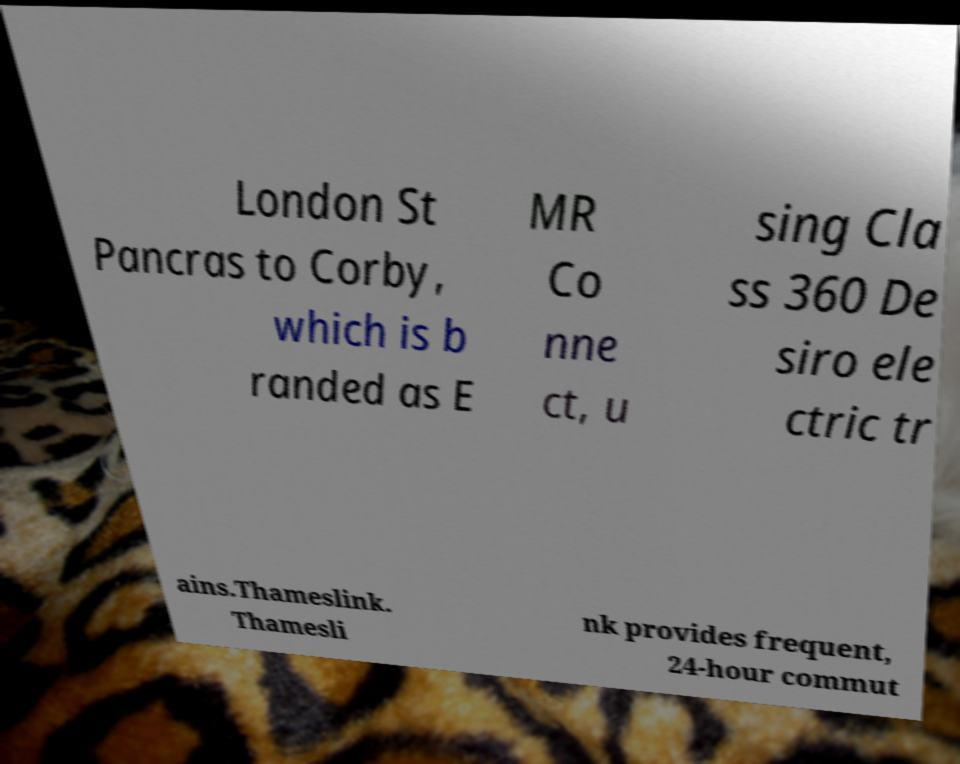Can you accurately transcribe the text from the provided image for me? London St Pancras to Corby, which is b randed as E MR Co nne ct, u sing Cla ss 360 De siro ele ctric tr ains.Thameslink. Thamesli nk provides frequent, 24-hour commut 